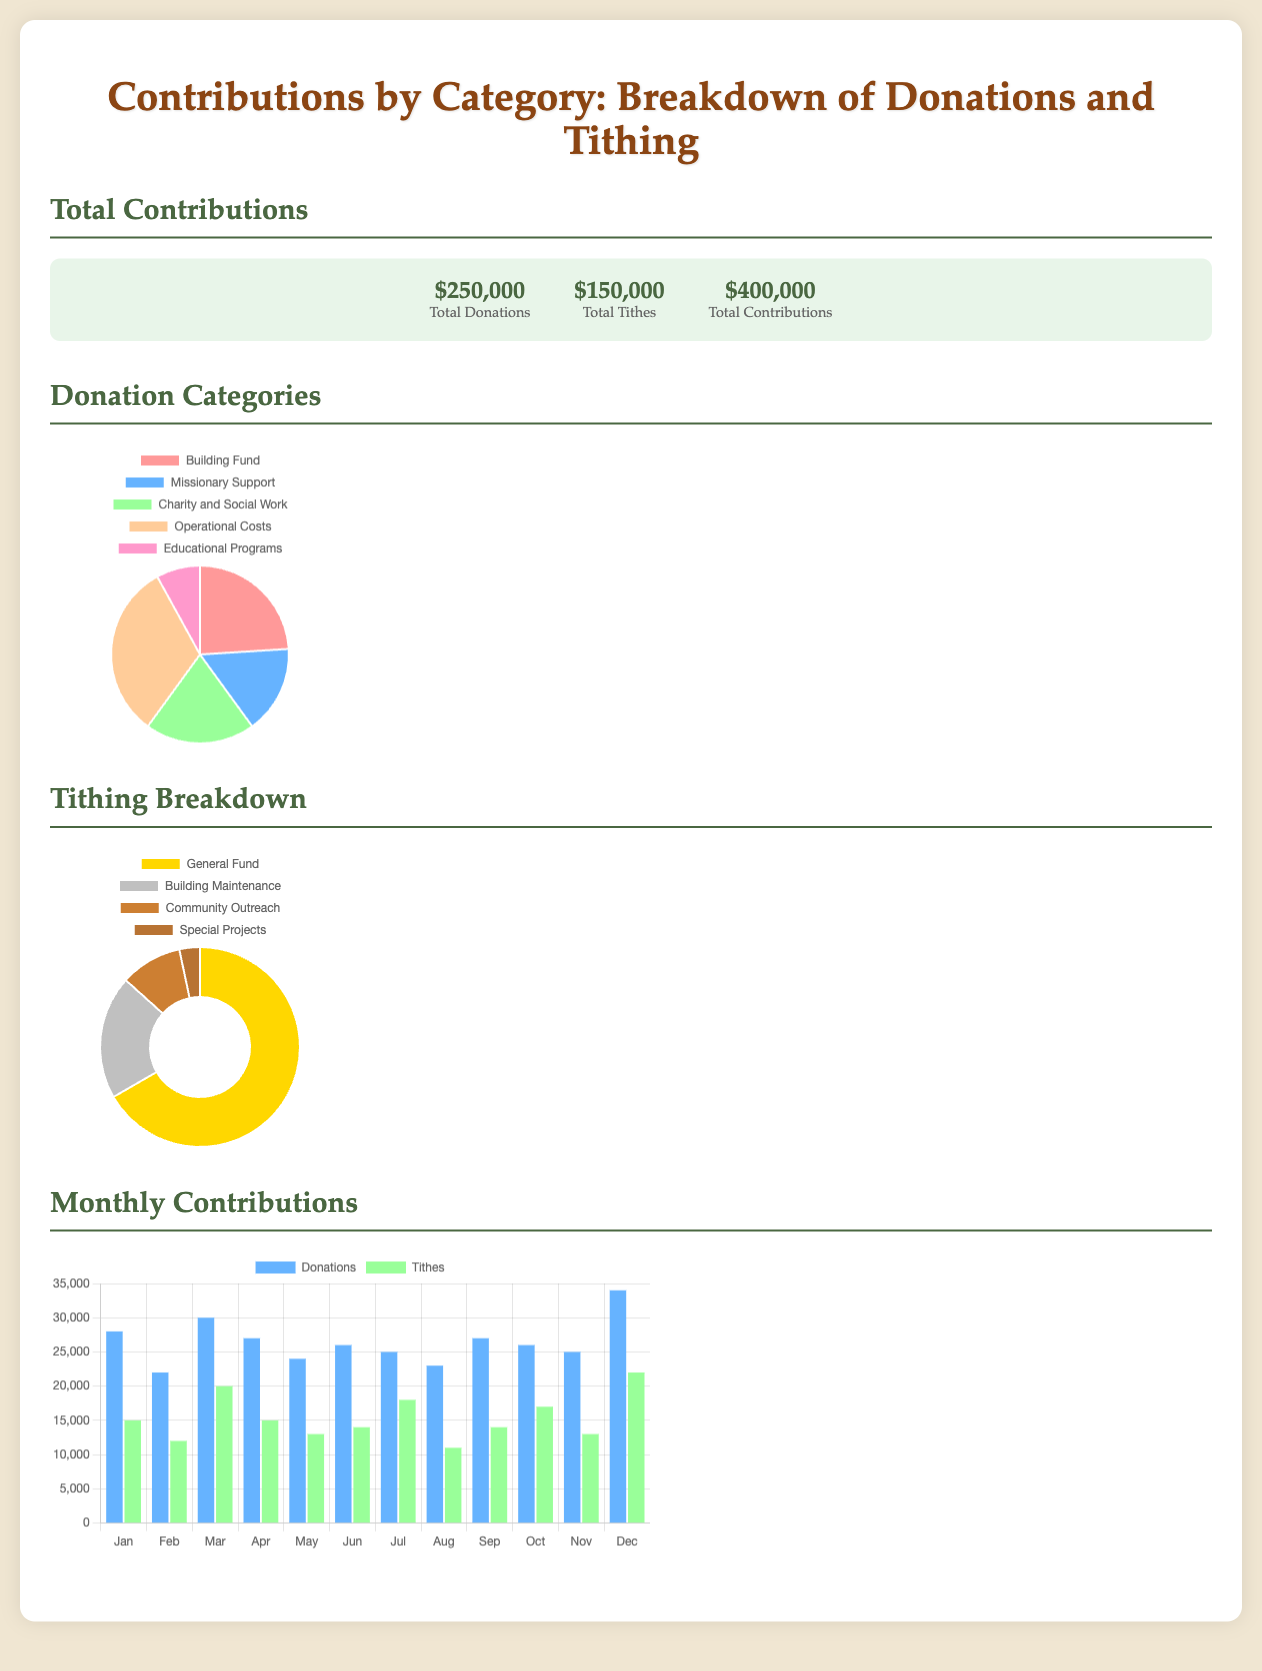What is the total amount of donations? The total amount of donations is explicitly stated in the document as $250,000.
Answer: $250,000 What is the largest category of donations? The largest category of donations, according to the pie chart, is Building Fund, which amounts to $60,000.
Answer: Building Fund How much was contributed to the General Fund in tithing? The amount contributed to the General Fund is given as $100,000 in the tithing breakdown.
Answer: $100,000 What is the total amount of tithes? The total amount of tithes is specified in the document as $150,000.
Answer: $150,000 Which month had the highest total donations in the monthly contributions chart? The month with the highest total donations is December, with $34,000.
Answer: December What percentage of total contributions comes from tithes? The percentage is calculated by dividing the total tithes by the total contributions, giving $150,000 / $400,000 = 37.5%.
Answer: 37.5% What is the total for Charity and Social Work donations? The total for Charity and Social Work donations is explicitly shown as $50,000 in the donation categories.
Answer: $50,000 What type of chart is used for the tithing breakdown? The tithing breakdown is displayed in a doughnut chart format.
Answer: Doughnut chart How many categories are listed under Donation Categories? There are a total of five categories listed under Donation Categories.
Answer: Five 